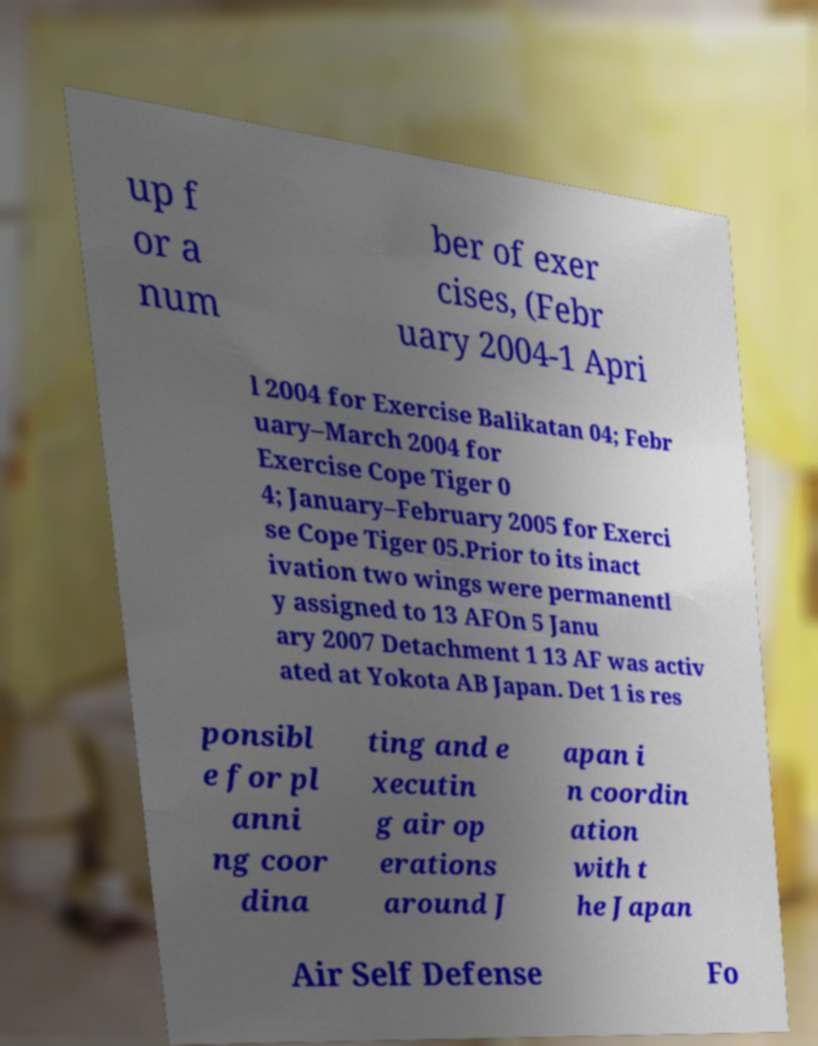There's text embedded in this image that I need extracted. Can you transcribe it verbatim? up f or a num ber of exer cises, (Febr uary 2004-1 Apri l 2004 for Exercise Balikatan 04; Febr uary–March 2004 for Exercise Cope Tiger 0 4; January–February 2005 for Exerci se Cope Tiger 05.Prior to its inact ivation two wings were permanentl y assigned to 13 AFOn 5 Janu ary 2007 Detachment 1 13 AF was activ ated at Yokota AB Japan. Det 1 is res ponsibl e for pl anni ng coor dina ting and e xecutin g air op erations around J apan i n coordin ation with t he Japan Air Self Defense Fo 